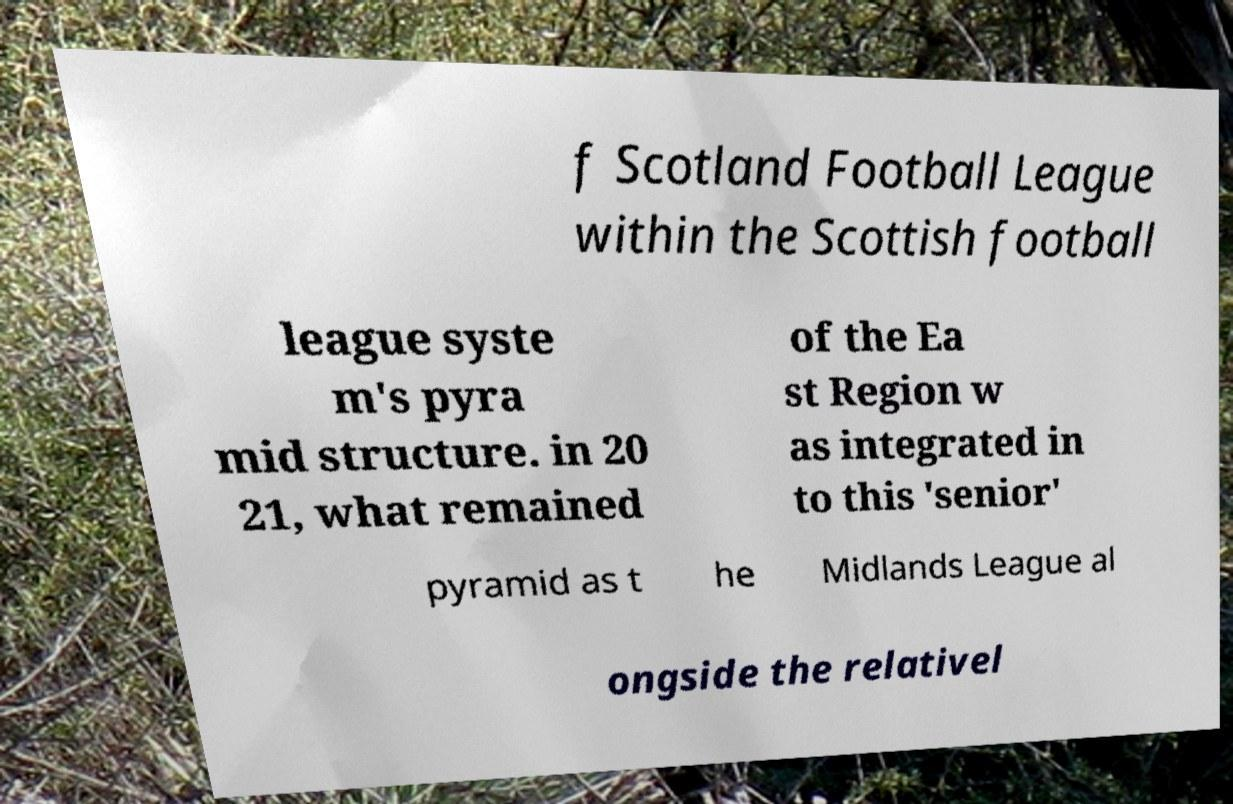Can you accurately transcribe the text from the provided image for me? f Scotland Football League within the Scottish football league syste m's pyra mid structure. in 20 21, what remained of the Ea st Region w as integrated in to this 'senior' pyramid as t he Midlands League al ongside the relativel 